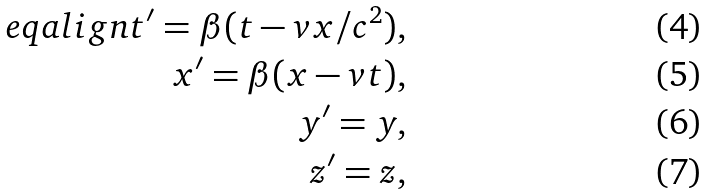<formula> <loc_0><loc_0><loc_500><loc_500>\ e q a l i g n t ^ { \prime } = \beta ( t - v x / c ^ { 2 } ) , \\ x ^ { \prime } = \beta ( x - v t ) , \\ y ^ { \prime } = y , \\ z ^ { \prime } = z ,</formula> 